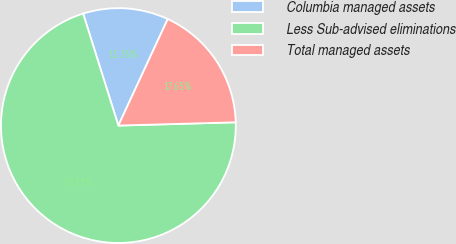<chart> <loc_0><loc_0><loc_500><loc_500><pie_chart><fcel>Columbia managed assets<fcel>Less Sub-advised eliminations<fcel>Total managed assets<nl><fcel>11.76%<fcel>70.59%<fcel>17.65%<nl></chart> 